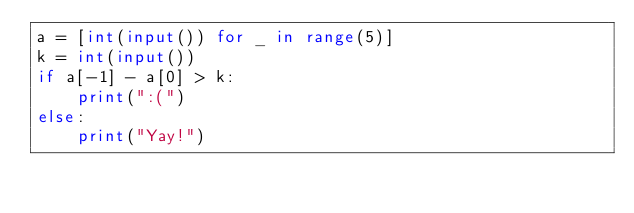Convert code to text. <code><loc_0><loc_0><loc_500><loc_500><_Python_>a = [int(input()) for _ in range(5)]
k = int(input())
if a[-1] - a[0] > k:
    print(":(")
else:
    print("Yay!")</code> 